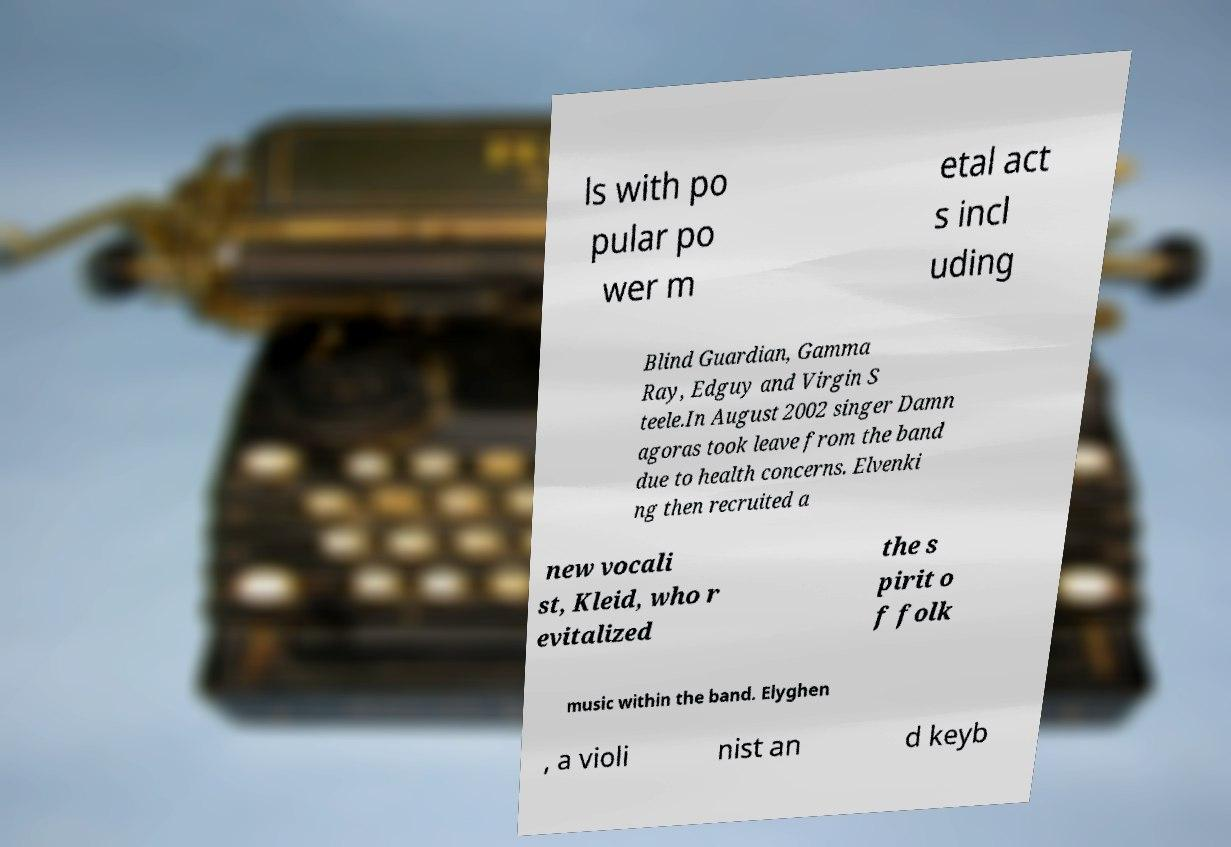Please read and relay the text visible in this image. What does it say? ls with po pular po wer m etal act s incl uding Blind Guardian, Gamma Ray, Edguy and Virgin S teele.In August 2002 singer Damn agoras took leave from the band due to health concerns. Elvenki ng then recruited a new vocali st, Kleid, who r evitalized the s pirit o f folk music within the band. Elyghen , a violi nist an d keyb 